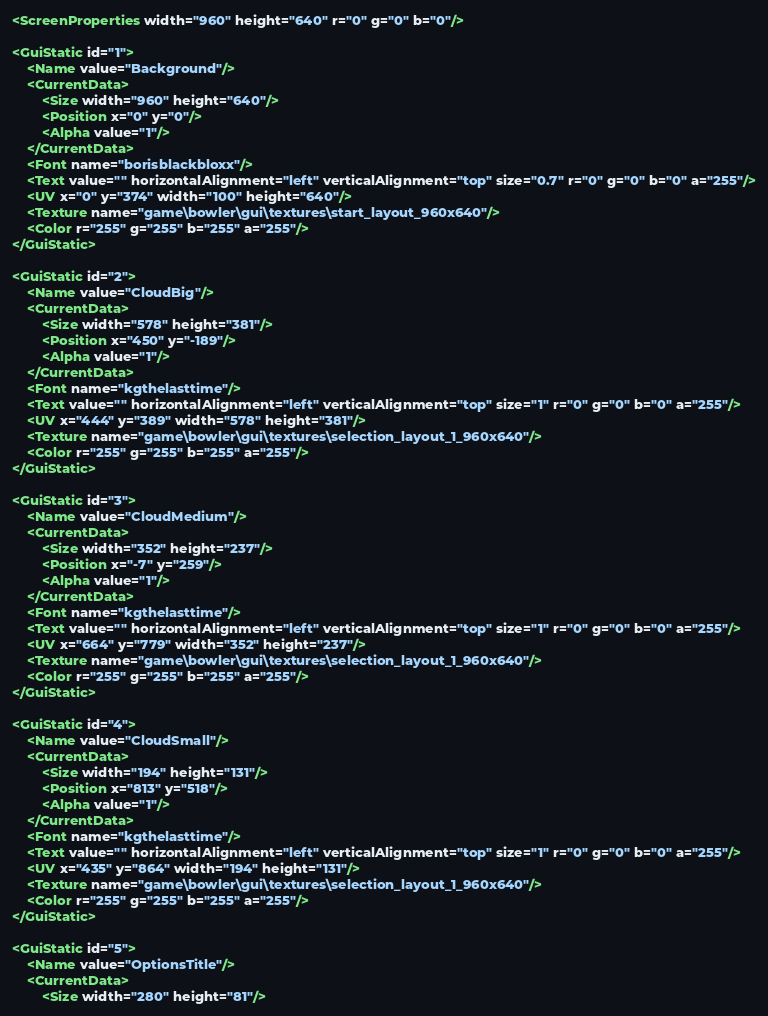Convert code to text. <code><loc_0><loc_0><loc_500><loc_500><_XML_><ScreenProperties width="960" height="640" r="0" g="0" b="0"/>

<GuiStatic id="1">
    <Name value="Background"/>
    <CurrentData>
        <Size width="960" height="640"/>
        <Position x="0" y="0"/>
        <Alpha value="1"/>
    </CurrentData>
    <Font name="borisblackbloxx"/>
    <Text value="" horizontalAlignment="left" verticalAlignment="top" size="0.7" r="0" g="0" b="0" a="255"/>
    <UV x="0" y="374" width="100" height="640"/>
    <Texture name="game\bowler\gui\textures\start_layout_960x640"/>
    <Color r="255" g="255" b="255" a="255"/>
</GuiStatic>

<GuiStatic id="2">
    <Name value="CloudBig"/>
    <CurrentData>
        <Size width="578" height="381"/>
        <Position x="450" y="-189"/>
        <Alpha value="1"/>
    </CurrentData>
    <Font name="kgthelasttime"/>
    <Text value="" horizontalAlignment="left" verticalAlignment="top" size="1" r="0" g="0" b="0" a="255"/>
    <UV x="444" y="389" width="578" height="381"/>
    <Texture name="game\bowler\gui\textures\selection_layout_1_960x640"/>
    <Color r="255" g="255" b="255" a="255"/>
</GuiStatic>

<GuiStatic id="3">
    <Name value="CloudMedium"/>
    <CurrentData>
        <Size width="352" height="237"/>
        <Position x="-7" y="259"/>
        <Alpha value="1"/>
    </CurrentData>
    <Font name="kgthelasttime"/>
    <Text value="" horizontalAlignment="left" verticalAlignment="top" size="1" r="0" g="0" b="0" a="255"/>
    <UV x="664" y="779" width="352" height="237"/>
    <Texture name="game\bowler\gui\textures\selection_layout_1_960x640"/>
    <Color r="255" g="255" b="255" a="255"/>
</GuiStatic>

<GuiStatic id="4">
    <Name value="CloudSmall"/>
    <CurrentData>
        <Size width="194" height="131"/>
        <Position x="813" y="518"/>
        <Alpha value="1"/>
    </CurrentData>
    <Font name="kgthelasttime"/>
    <Text value="" horizontalAlignment="left" verticalAlignment="top" size="1" r="0" g="0" b="0" a="255"/>
    <UV x="435" y="864" width="194" height="131"/>
    <Texture name="game\bowler\gui\textures\selection_layout_1_960x640"/>
    <Color r="255" g="255" b="255" a="255"/>
</GuiStatic>

<GuiStatic id="5">
    <Name value="OptionsTitle"/>
    <CurrentData>
        <Size width="280" height="81"/></code> 